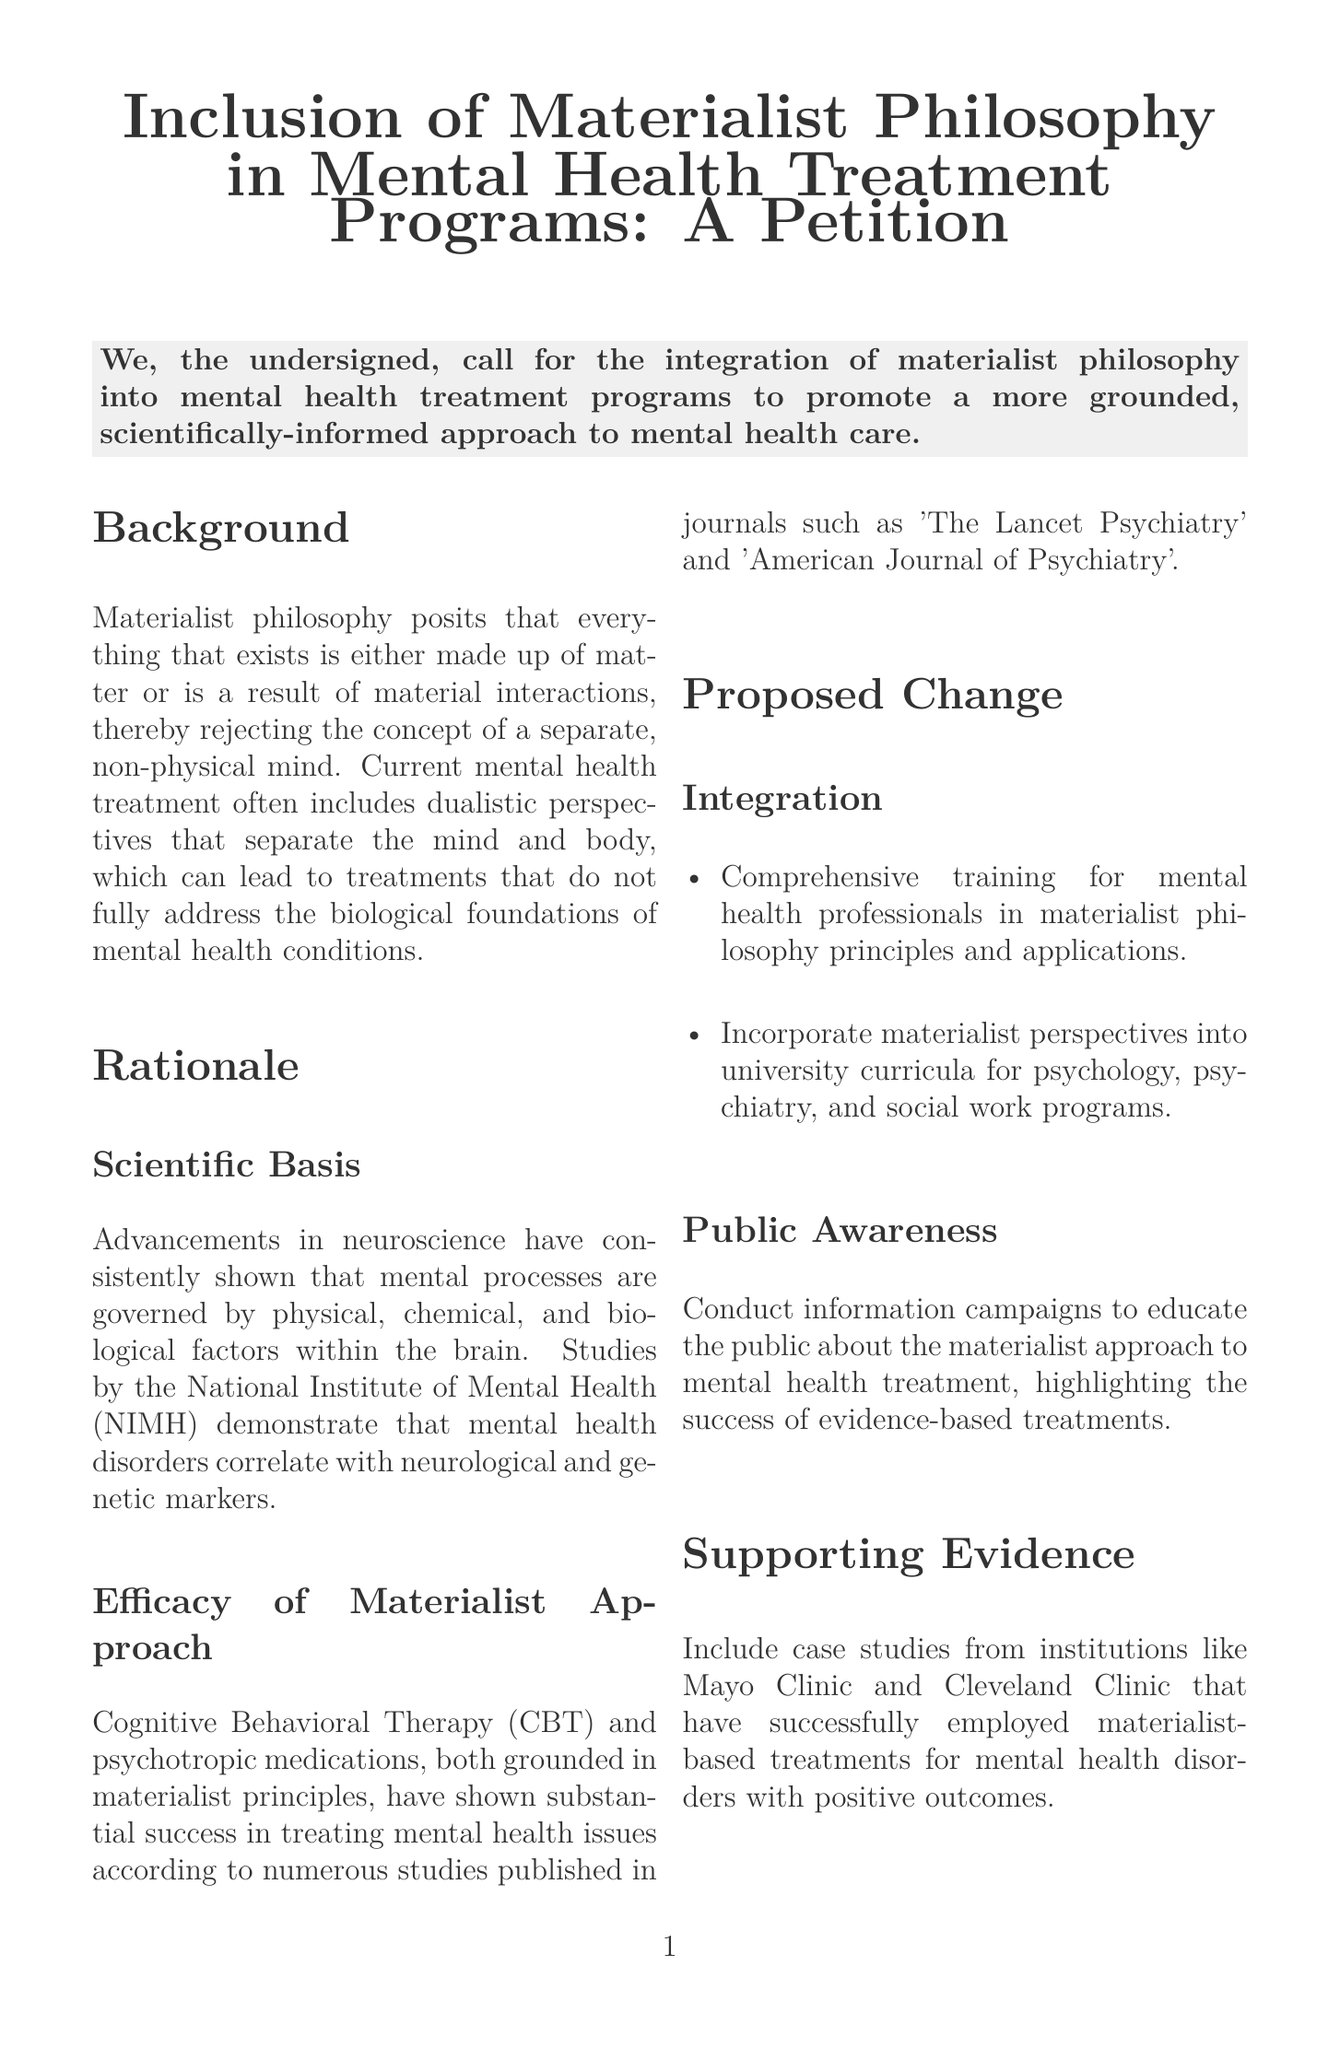What is the main goal of the petition? The main goal of the petition is stated in the introduction and revolves around the integration of materialist philosophy into mental health treatment programs.
Answer: Integration of materialist philosophy into mental health treatment programs What does materialist philosophy reject? The background section outlines that materialist philosophy rejects the concept of a separate, non-physical mind.
Answer: The concept of a separate, non-physical mind Which organization’s studies are mentioned regarding the correlation with mental health disorders? The rationale section cites studies from the National Institute of Mental Health, which demonstrate the correlation of mental health disorders with certain factors.
Answer: National Institute of Mental Health (NIMH) Name one successful therapy grounded in materialist principles. The rationale section mentions Cognitive Behavioral Therapy as a successful treatment grounded in materialist principles.
Answer: Cognitive Behavioral Therapy (CBT) What training is proposed for mental health professionals? The proposed change section suggests comprehensive training for mental health professionals in materialist philosophy principles and applications.
Answer: Comprehensive training in materialist philosophy principles Which clinics are mentioned as supporting evidence for materialist-based treatments? The supporting evidence section refers to case studies from Mayo Clinic and Cleveland Clinic as institutions that have successfully employed materialist-based treatments.
Answer: Mayo Clinic and Cleveland Clinic In what areas should materialist perspectives be incorporated according to the petition? The proposed change section states that materialist perspectives should be incorporated into university curricula for psychology, psychiatry, and social work programs.
Answer: University curricula for psychology, psychiatry, and social work programs What type of campaigns are suggested for public awareness? The proposed change section mentions conducting information campaigns to educate the public about the materialist approach to mental health treatment.
Answer: Information campaigns What is the desired outcome of embracing materialist philosophy in mental health treatment? The conclusion states that embracing materialist philosophy in mental health treatment programs is expected to lead to more effective and scientifically grounded treatments.
Answer: More effective and scientifically grounded treatments 